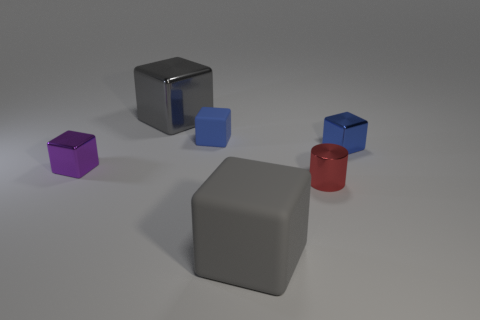Is the color of the cylinder the same as the small rubber cube?
Provide a succinct answer. No. How many small matte cubes have the same color as the large metal thing?
Offer a terse response. 0. There is a cube that is on the left side of the gray cube that is behind the small purple metallic cube; what size is it?
Keep it short and to the point. Small. What shape is the small blue matte object?
Your answer should be compact. Cube. There is a tiny blue cube that is to the right of the large gray matte object; what is it made of?
Provide a short and direct response. Metal. What is the color of the large object behind the small metallic cube that is on the right side of the large gray thing to the left of the large gray matte thing?
Make the answer very short. Gray. The metallic cube that is the same size as the gray matte thing is what color?
Your answer should be very brief. Gray. What number of metal objects are either small blue objects or gray blocks?
Provide a succinct answer. 2. What color is the big object that is the same material as the tiny cylinder?
Provide a short and direct response. Gray. There is a blue thing to the left of the big block that is on the right side of the large gray shiny block; what is its material?
Your answer should be very brief. Rubber. 